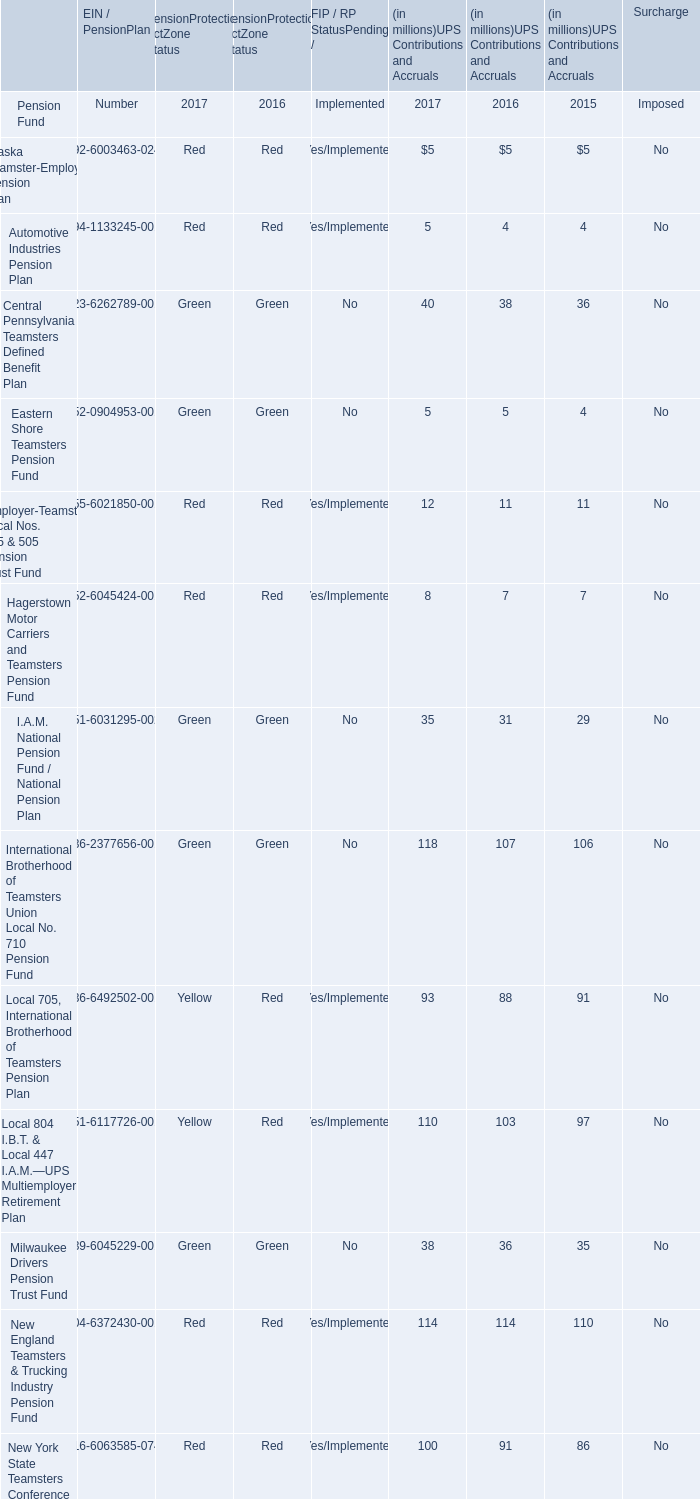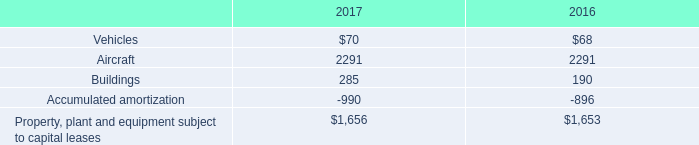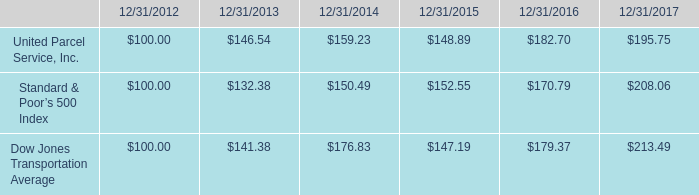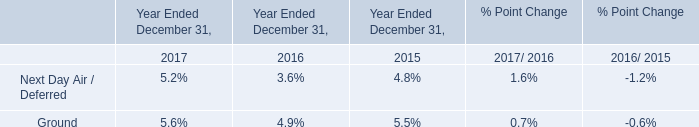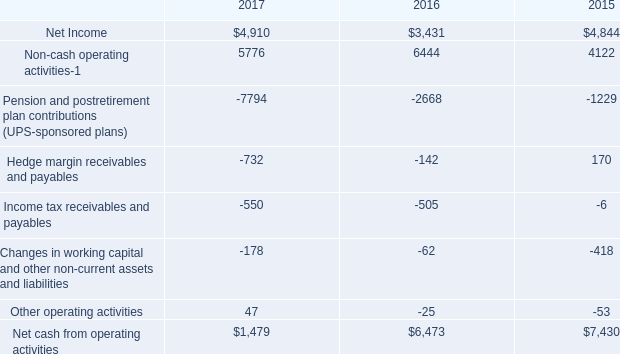what was the percentage change in building under capital lease from 2016 to 2017? 
Computations: ((285 - 190) / 190)
Answer: 0.5. 